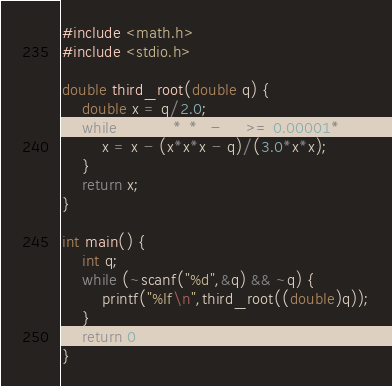Convert code to text. <code><loc_0><loc_0><loc_500><loc_500><_C_>#include <math.h>
#include <stdio.h>

double third_root(double q) {
	double x = q/2.0;
	while (fabs(x*x*x - q) >= 0.00001*q) {
		x = x - (x*x*x - q)/(3.0*x*x);
	}
	return x;
}

int main() {
	int q;
	while (~scanf("%d",&q) && ~q) {
		printf("%lf\n",third_root((double)q));
	}
	return 0;
}</code> 